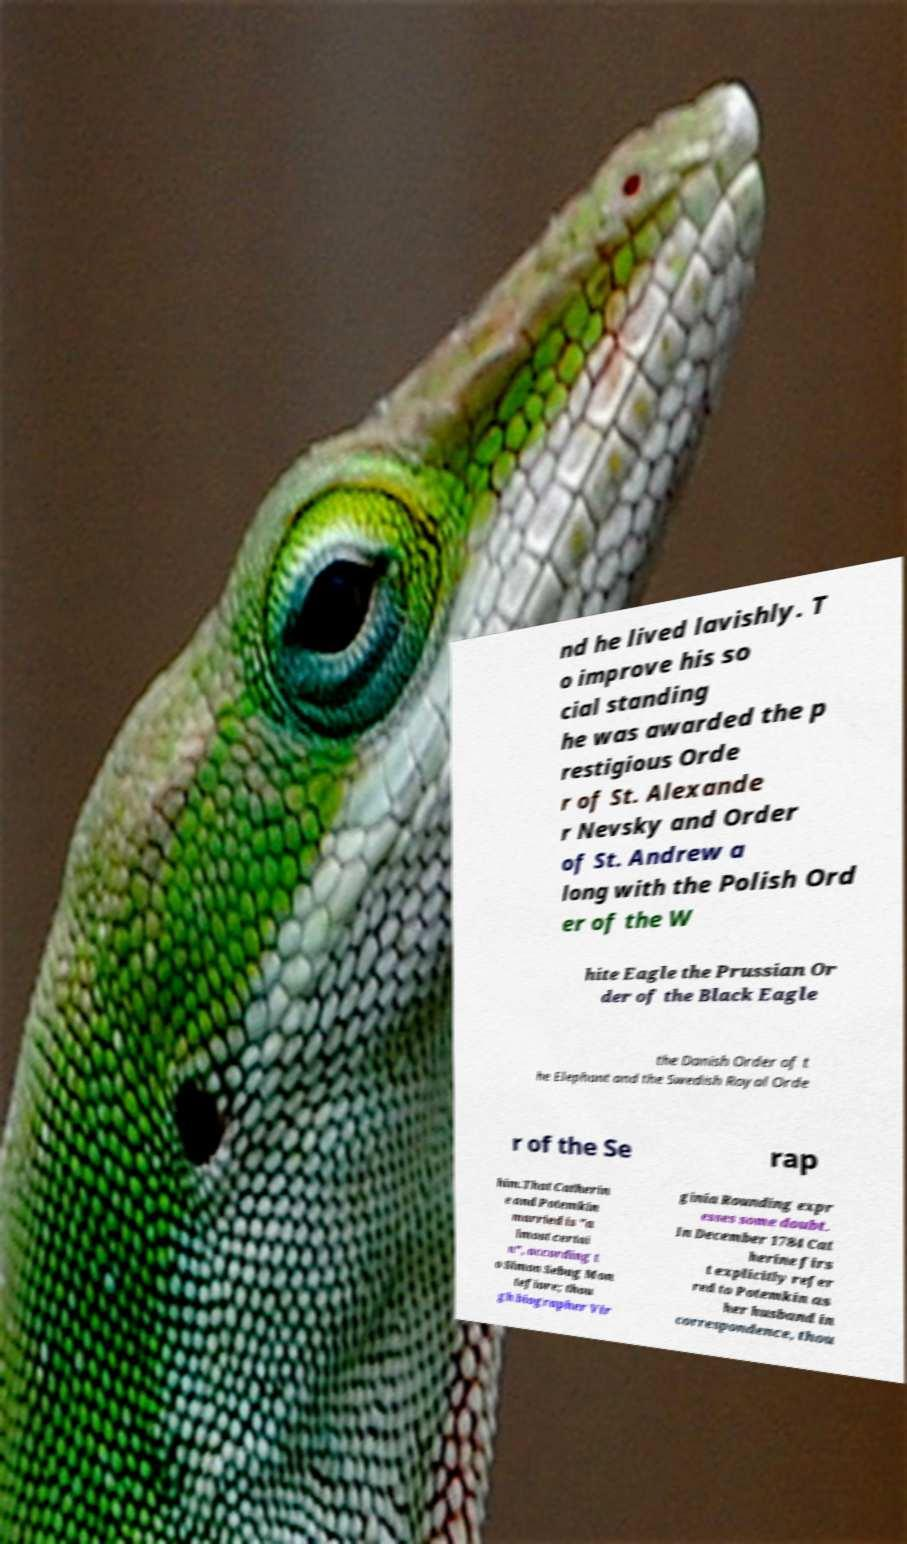Please identify and transcribe the text found in this image. nd he lived lavishly. T o improve his so cial standing he was awarded the p restigious Orde r of St. Alexande r Nevsky and Order of St. Andrew a long with the Polish Ord er of the W hite Eagle the Prussian Or der of the Black Eagle the Danish Order of t he Elephant and the Swedish Royal Orde r of the Se rap him.That Catherin e and Potemkin married is "a lmost certai n", according t o Simon Sebag Mon tefiore; thou gh biographer Vir ginia Rounding expr esses some doubt. In December 1784 Cat herine firs t explicitly refer red to Potemkin as her husband in correspondence, thou 